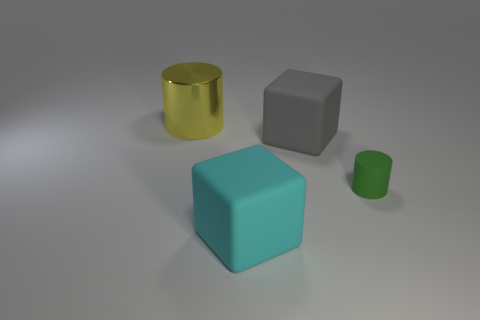Add 4 purple matte spheres. How many objects exist? 8 Subtract 1 cylinders. How many cylinders are left? 1 Add 2 tiny green objects. How many tiny green objects are left? 3 Add 2 tiny green matte cylinders. How many tiny green matte cylinders exist? 3 Subtract 1 yellow cylinders. How many objects are left? 3 Subtract all red cylinders. Subtract all brown balls. How many cylinders are left? 2 Subtract all green matte things. Subtract all yellow metallic things. How many objects are left? 2 